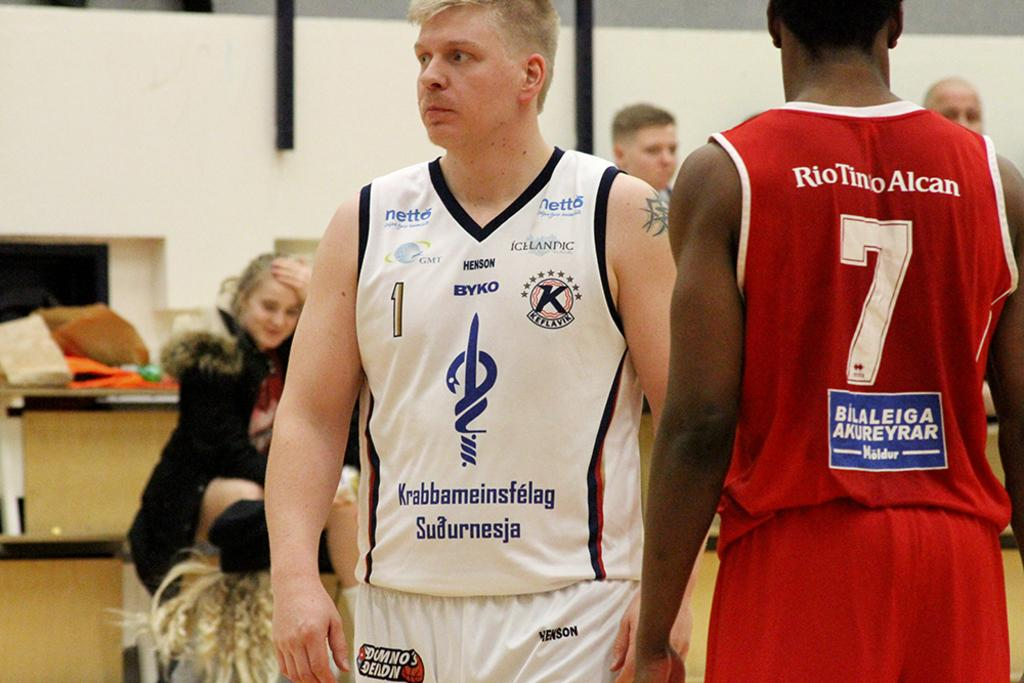<image>
Offer a succinct explanation of the picture presented. Sports athlete wearing a white uniform with Krabbameinsfelag Sudurnesja in blue lettering. 